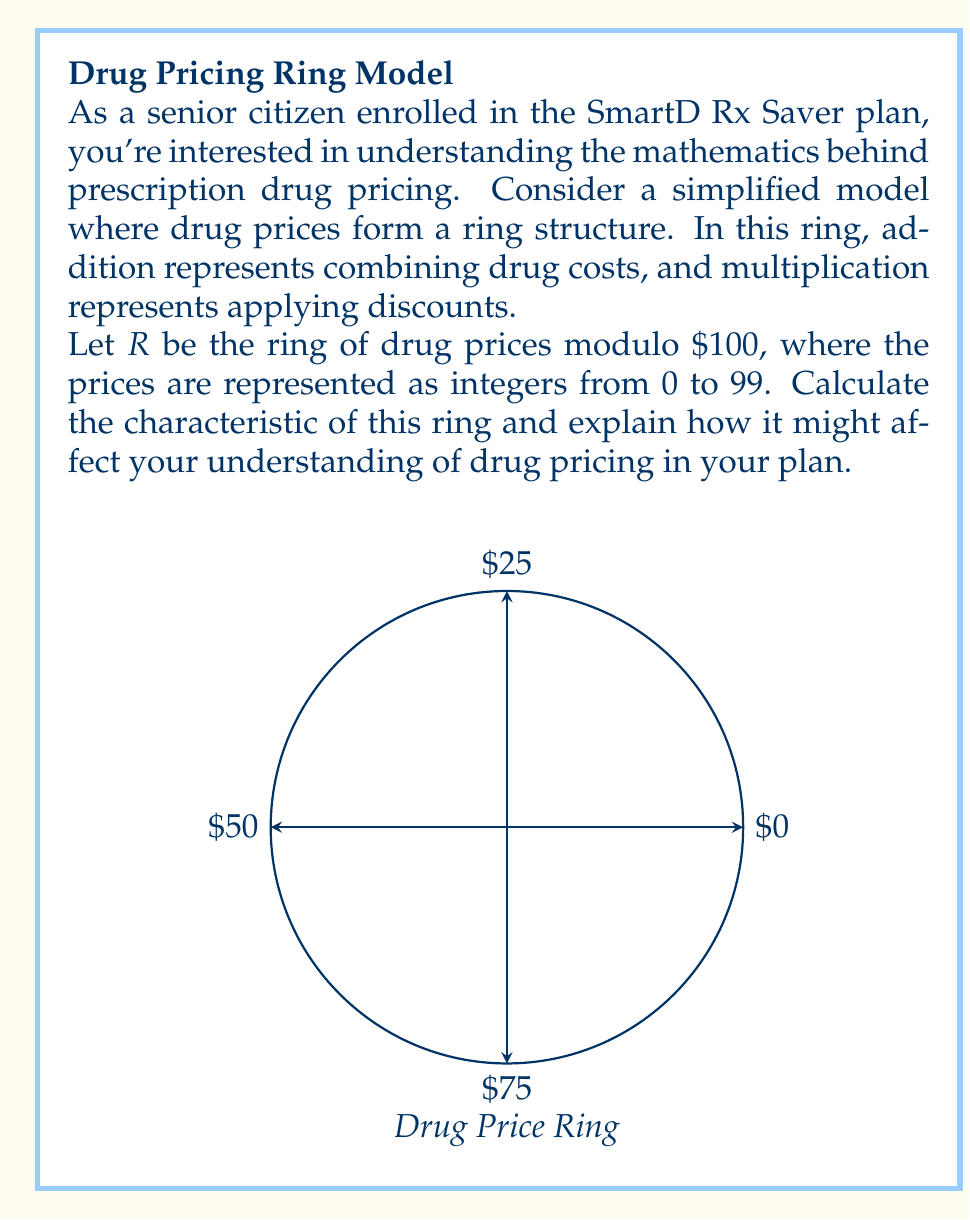Teach me how to tackle this problem. Let's approach this step-by-step:

1) First, recall that the characteristic of a ring is the smallest positive integer $n$ such that $n \cdot 1 = 0$ in the ring, where $1$ is the multiplicative identity. If no such integer exists, the characteristic is said to be 0.

2) In our ring $R$, addition is modulo $100$. This means:
   $$(a + b) \mod 100 = ((a \mod 100) + (b \mod 100)) \mod 100$$

3) The multiplicative identity in this ring is $1$, as $1 \cdot x \mod 100 = x \mod 100$ for all $x$.

4) To find the characteristic, we need to find the smallest positive integer $n$ such that:
   $$n \cdot 1 \equiv 0 \pmod{100}$$

5) This is equivalent to finding the smallest $n$ where $100$ divides $n$.

6) Clearly, $n = 100$ satisfies this condition, and it's the smallest positive integer to do so.

7) Therefore, the characteristic of this ring is 100.

Implications for drug pricing:

a) In this model, drug prices "wrap around" every $\$100$. This could represent a price cap or a cyclical nature in the pricing structure.

b) The characteristic being 100 means that adding a drug price to itself 100 times always results in the original price. This could be interpreted as a limit on cumulative costs or discounts.

c) For the SmartD Rx Saver plan, this might suggest that there's a maximum out-of-pocket cost, or that certain discounts or benefits reset after reaching a $\$100$ threshold.

d) Understanding this structure could help in planning medication costs, as it provides a predictable pattern for how prices combine and how discounts apply within the $\$100$ cycle.
Answer: The characteristic of the ring is 100. 